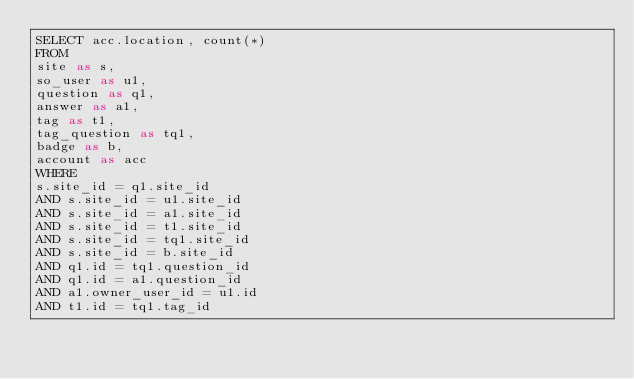<code> <loc_0><loc_0><loc_500><loc_500><_SQL_>SELECT acc.location, count(*)
FROM
site as s,
so_user as u1,
question as q1,
answer as a1,
tag as t1,
tag_question as tq1,
badge as b,
account as acc
WHERE
s.site_id = q1.site_id
AND s.site_id = u1.site_id
AND s.site_id = a1.site_id
AND s.site_id = t1.site_id
AND s.site_id = tq1.site_id
AND s.site_id = b.site_id
AND q1.id = tq1.question_id
AND q1.id = a1.question_id
AND a1.owner_user_id = u1.id
AND t1.id = tq1.tag_id</code> 